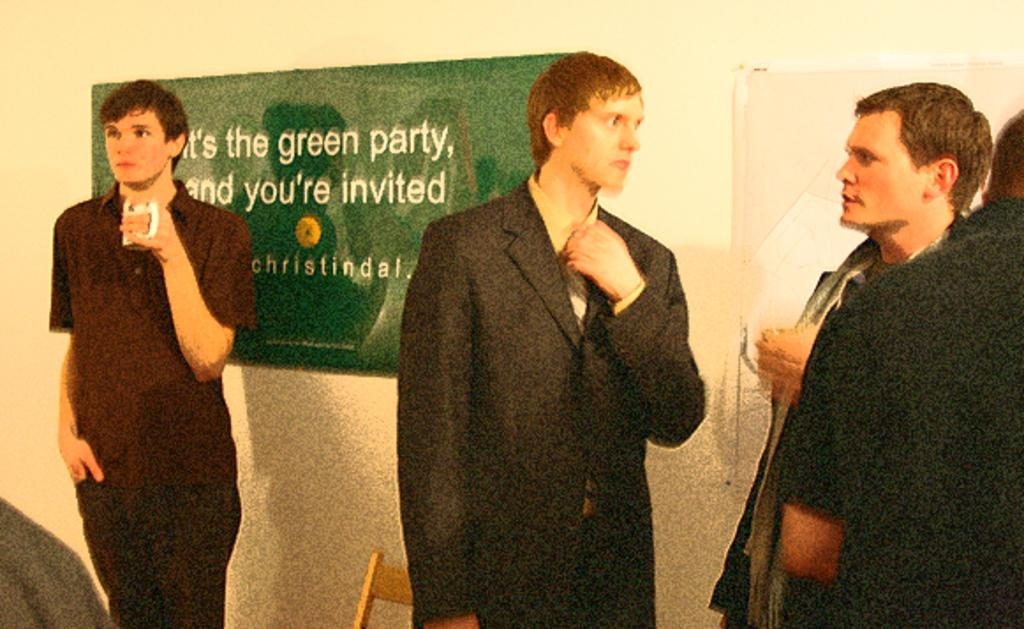What is happening in the center of the image? There are people standing in the center of the image. What can be seen in the background of the image? There is a board and a wall in the background of the image. Can you see any ghosts interacting with the people in the image? There are no ghosts present in the image. What type of harbor can be seen in the background of the image? There is no harbor present in the image; it only features a board and a wall in the background. 